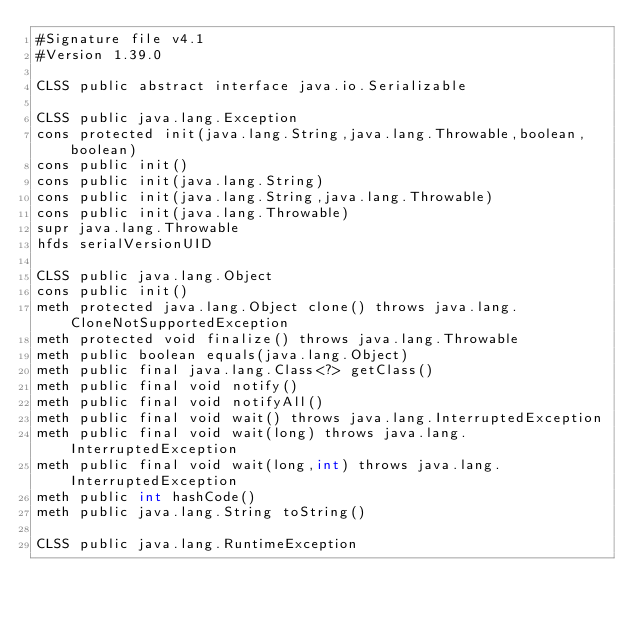<code> <loc_0><loc_0><loc_500><loc_500><_SML_>#Signature file v4.1
#Version 1.39.0

CLSS public abstract interface java.io.Serializable

CLSS public java.lang.Exception
cons protected init(java.lang.String,java.lang.Throwable,boolean,boolean)
cons public init()
cons public init(java.lang.String)
cons public init(java.lang.String,java.lang.Throwable)
cons public init(java.lang.Throwable)
supr java.lang.Throwable
hfds serialVersionUID

CLSS public java.lang.Object
cons public init()
meth protected java.lang.Object clone() throws java.lang.CloneNotSupportedException
meth protected void finalize() throws java.lang.Throwable
meth public boolean equals(java.lang.Object)
meth public final java.lang.Class<?> getClass()
meth public final void notify()
meth public final void notifyAll()
meth public final void wait() throws java.lang.InterruptedException
meth public final void wait(long) throws java.lang.InterruptedException
meth public final void wait(long,int) throws java.lang.InterruptedException
meth public int hashCode()
meth public java.lang.String toString()

CLSS public java.lang.RuntimeException</code> 